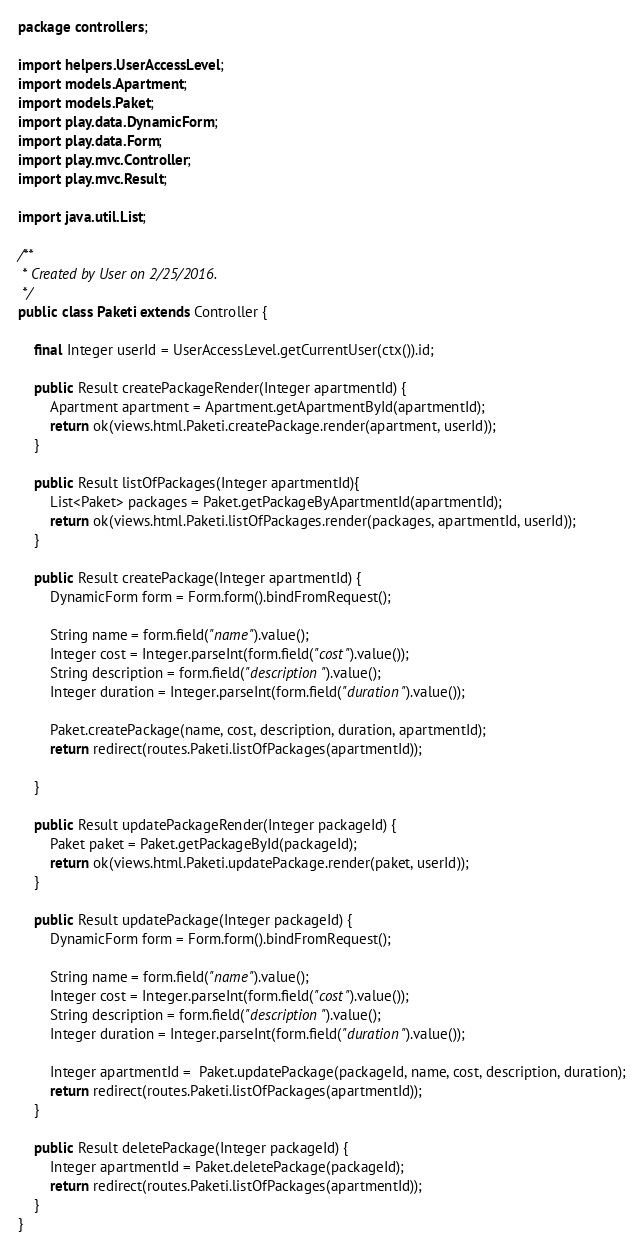<code> <loc_0><loc_0><loc_500><loc_500><_Java_>package controllers;

import helpers.UserAccessLevel;
import models.Apartment;
import models.Paket;
import play.data.DynamicForm;
import play.data.Form;
import play.mvc.Controller;
import play.mvc.Result;

import java.util.List;

/**
 * Created by User on 2/25/2016.
 */
public class Paketi extends Controller {

    final Integer userId = UserAccessLevel.getCurrentUser(ctx()).id;

    public Result createPackageRender(Integer apartmentId) {
        Apartment apartment = Apartment.getApartmentById(apartmentId);
        return ok(views.html.Paketi.createPackage.render(apartment, userId));
    }

    public Result listOfPackages(Integer apartmentId){
        List<Paket> packages = Paket.getPackageByApartmentId(apartmentId);
        return ok(views.html.Paketi.listOfPackages.render(packages, apartmentId, userId));
    }

    public Result createPackage(Integer apartmentId) {
        DynamicForm form = Form.form().bindFromRequest();

        String name = form.field("name").value();
        Integer cost = Integer.parseInt(form.field("cost").value());
        String description = form.field("description").value();
        Integer duration = Integer.parseInt(form.field("duration").value());

        Paket.createPackage(name, cost, description, duration, apartmentId);
        return redirect(routes.Paketi.listOfPackages(apartmentId));

    }

    public Result updatePackageRender(Integer packageId) {
        Paket paket = Paket.getPackageById(packageId);
        return ok(views.html.Paketi.updatePackage.render(paket, userId));
    }

    public Result updatePackage(Integer packageId) {
        DynamicForm form = Form.form().bindFromRequest();

        String name = form.field("name").value();
        Integer cost = Integer.parseInt(form.field("cost").value());
        String description = form.field("description").value();
        Integer duration = Integer.parseInt(form.field("duration").value());

        Integer apartmentId =  Paket.updatePackage(packageId, name, cost, description, duration);
        return redirect(routes.Paketi.listOfPackages(apartmentId));
    }

    public Result deletePackage(Integer packageId) {
        Integer apartmentId = Paket.deletePackage(packageId);
        return redirect(routes.Paketi.listOfPackages(apartmentId));
    }
}
</code> 